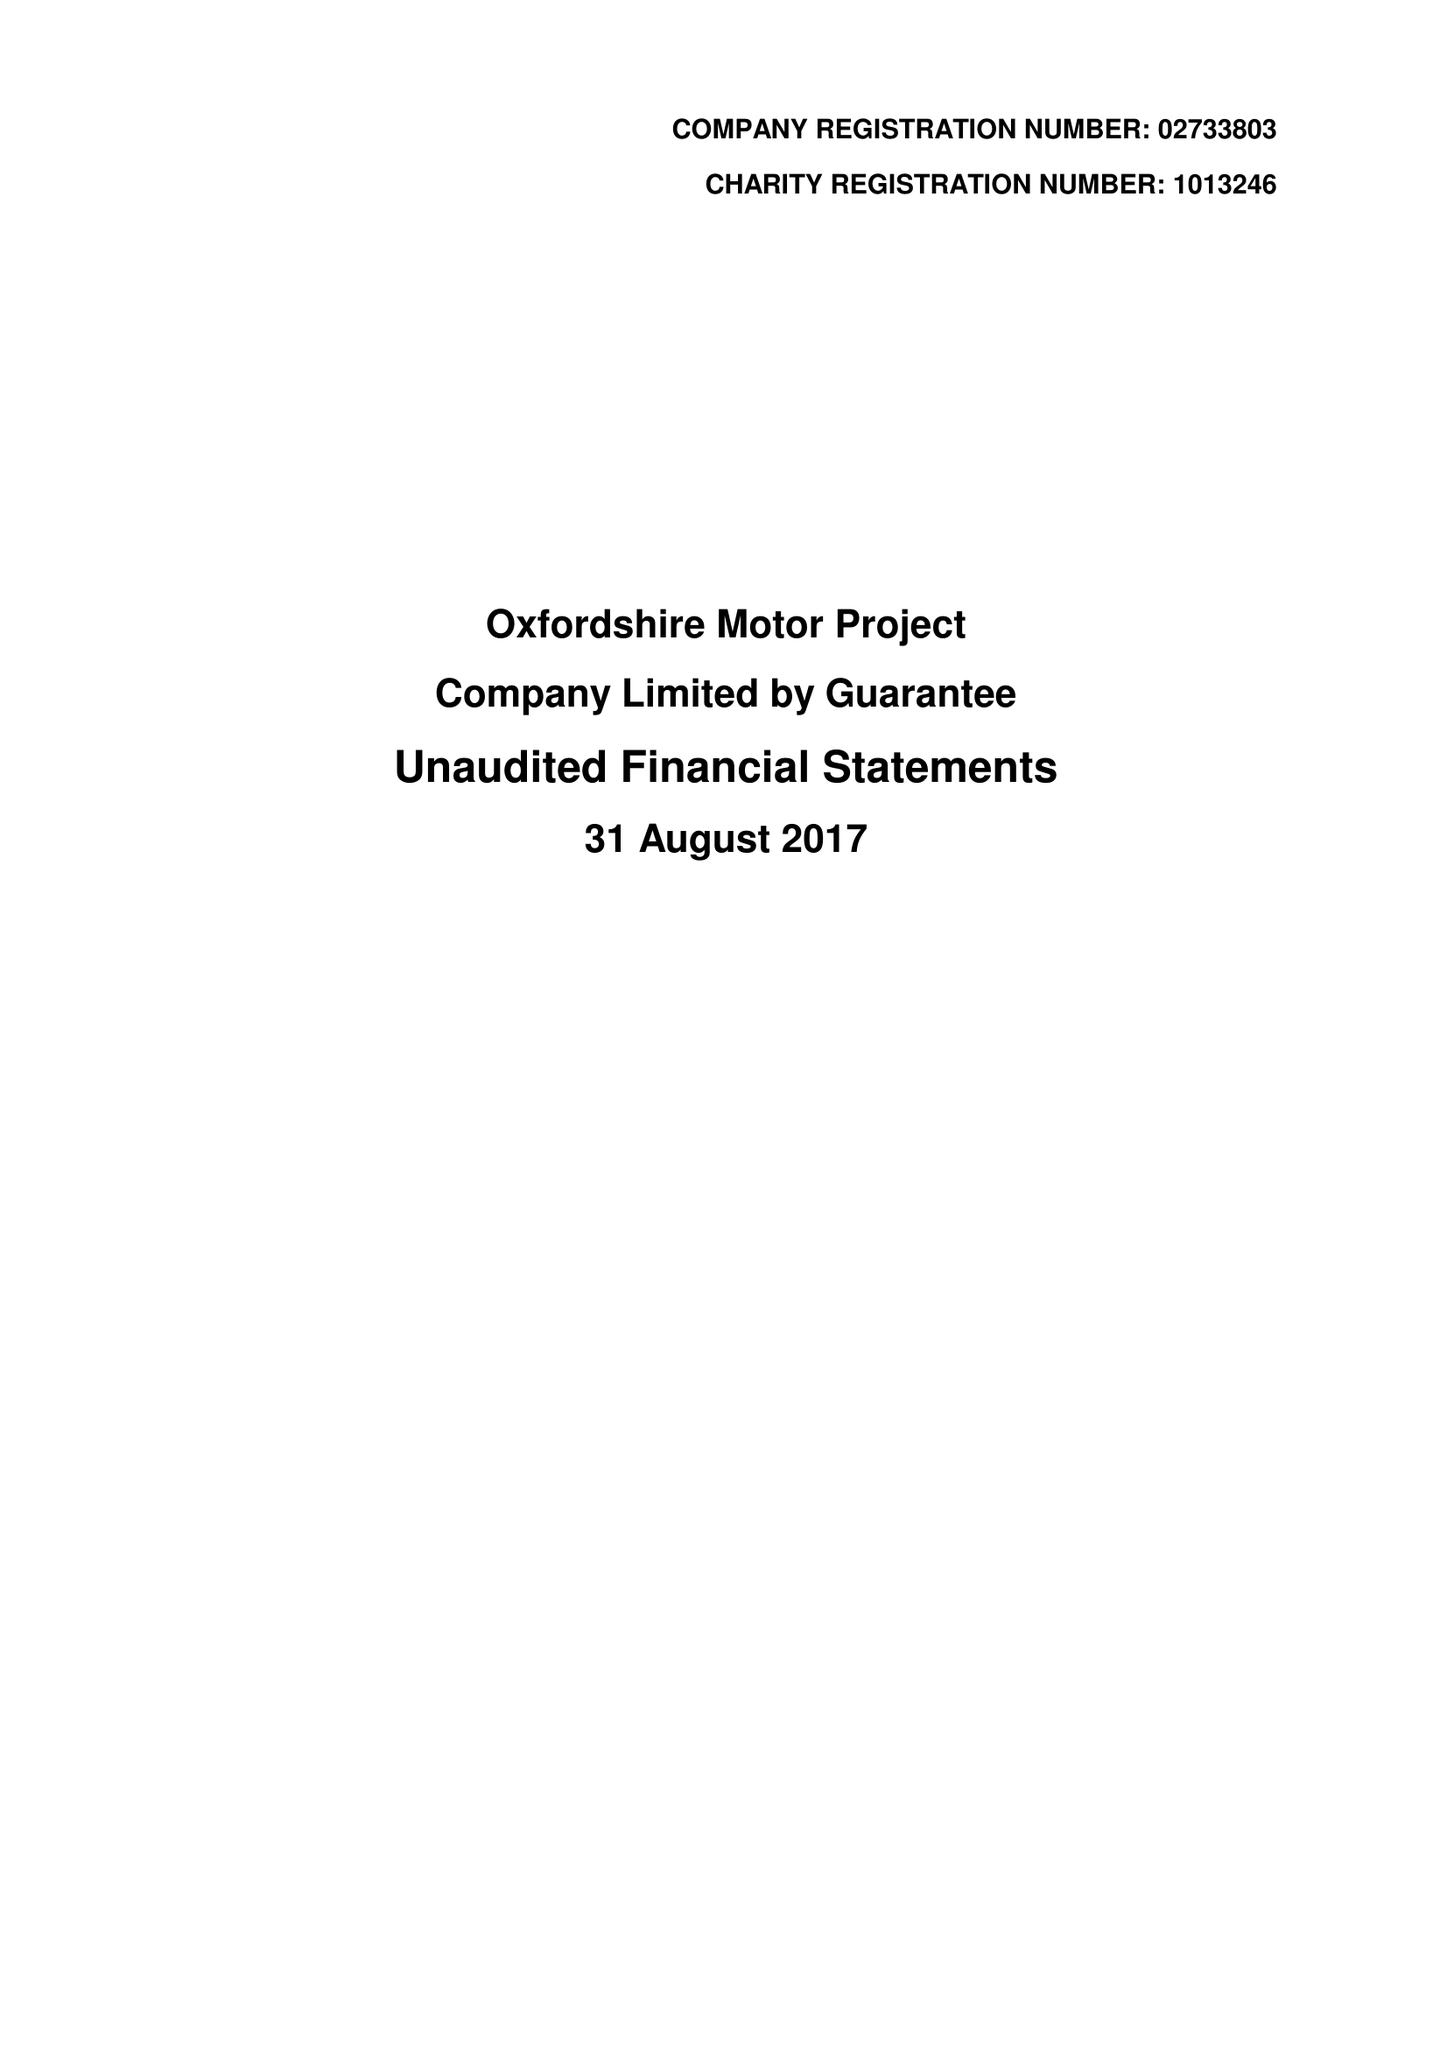What is the value for the charity_number?
Answer the question using a single word or phrase. 1013246 